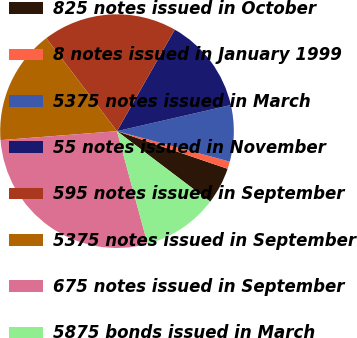Convert chart to OTSL. <chart><loc_0><loc_0><loc_500><loc_500><pie_chart><fcel>825 notes issued in October<fcel>8 notes issued in January 1999<fcel>5375 notes issued in March<fcel>55 notes issued in November<fcel>595 notes issued in September<fcel>5375 notes issued in September<fcel>675 notes issued in September<fcel>5875 bonds issued in March<nl><fcel>5.09%<fcel>1.02%<fcel>7.79%<fcel>13.18%<fcel>18.58%<fcel>15.88%<fcel>27.99%<fcel>10.48%<nl></chart> 